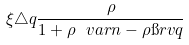<formula> <loc_0><loc_0><loc_500><loc_500>\xi \triangle q \frac { \rho } { 1 + \rho \ v a r n - \rho \i r v q }</formula> 